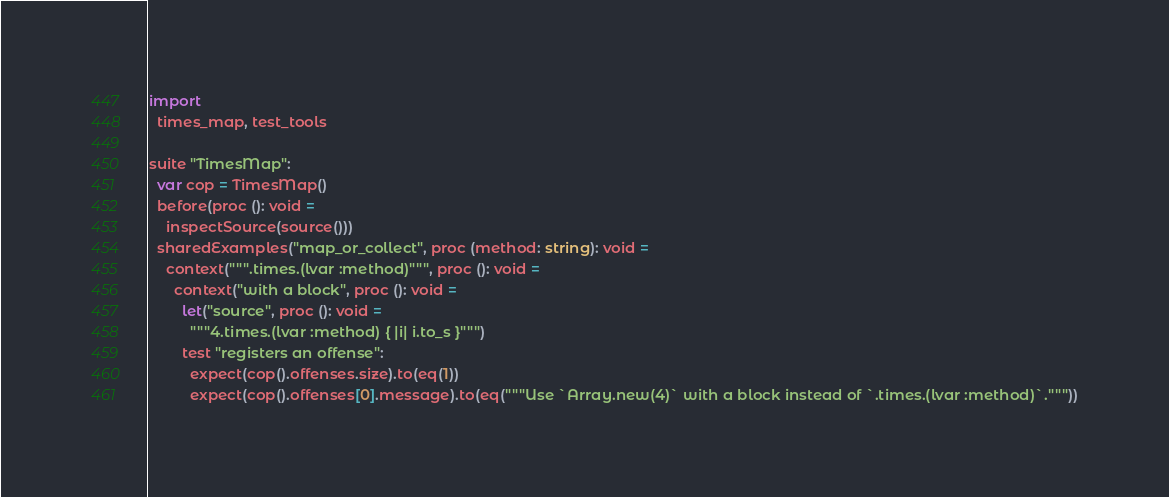Convert code to text. <code><loc_0><loc_0><loc_500><loc_500><_Nim_>
import
  times_map, test_tools

suite "TimesMap":
  var cop = TimesMap()
  before(proc (): void =
    inspectSource(source()))
  sharedExamples("map_or_collect", proc (method: string): void =
    context(""".times.(lvar :method)""", proc (): void =
      context("with a block", proc (): void =
        let("source", proc (): void =
          """4.times.(lvar :method) { |i| i.to_s }""")
        test "registers an offense":
          expect(cop().offenses.size).to(eq(1))
          expect(cop().offenses[0].message).to(eq("""Use `Array.new(4)` with a block instead of `.times.(lvar :method)`."""))</code> 